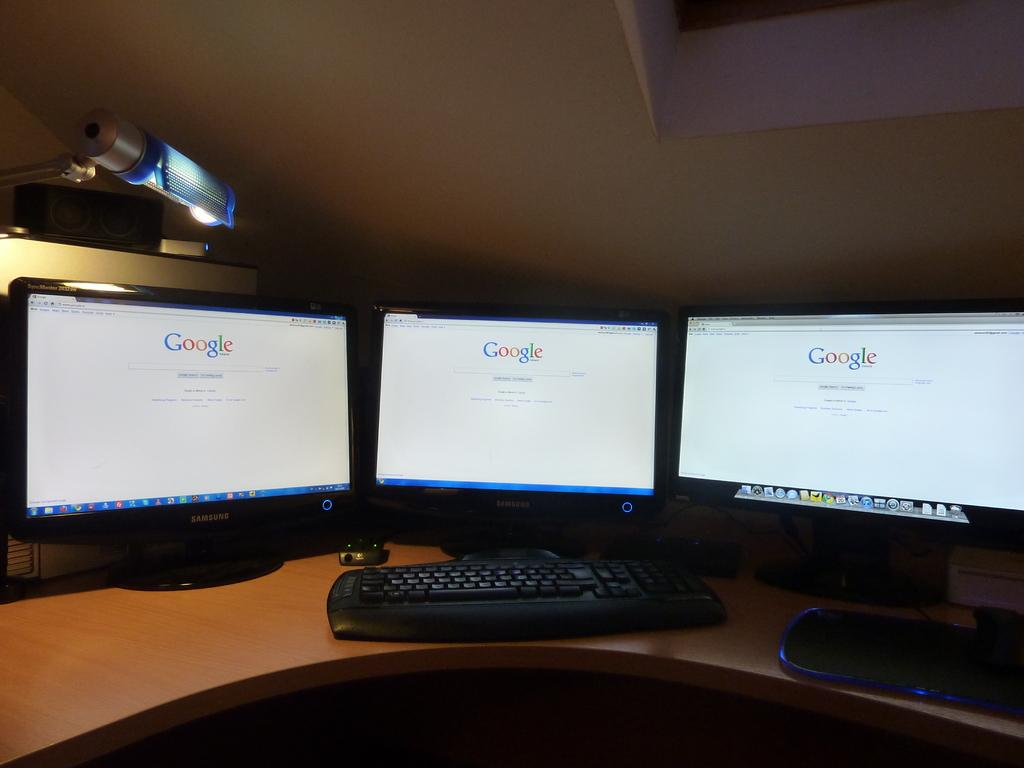<image>
Describe the image concisely. Three monitors on a table showing Google on the screen. 